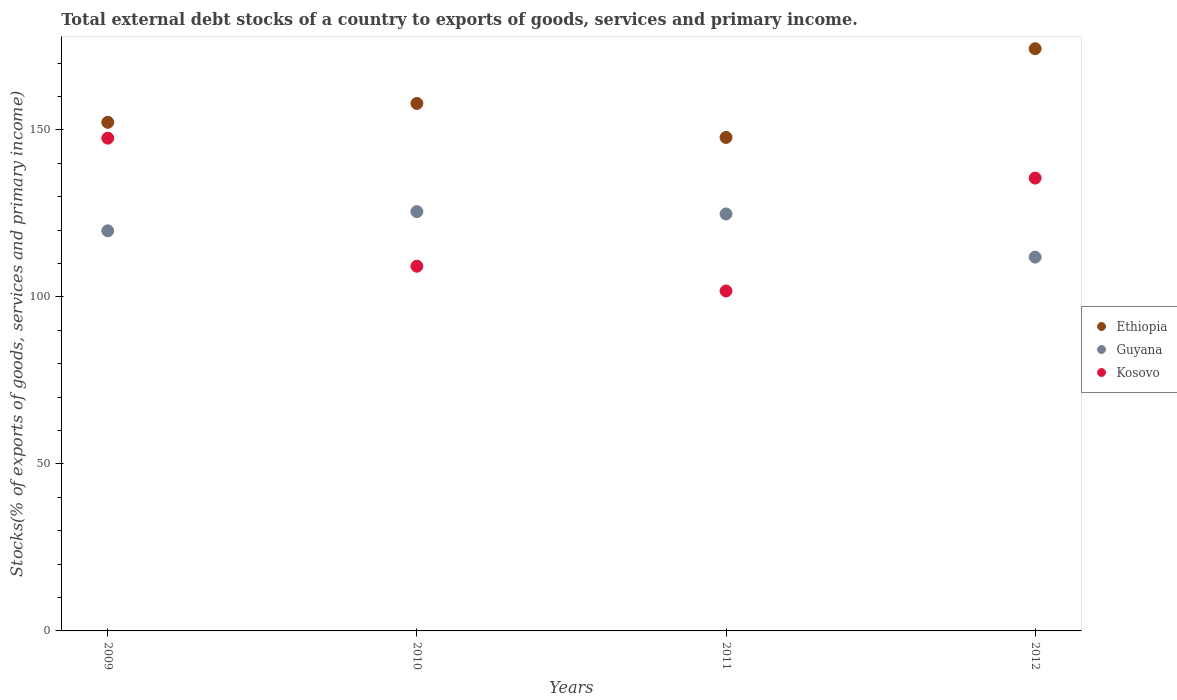What is the total debt stocks in Kosovo in 2010?
Provide a succinct answer. 109.18. Across all years, what is the maximum total debt stocks in Guyana?
Your answer should be compact. 125.53. Across all years, what is the minimum total debt stocks in Ethiopia?
Offer a terse response. 147.73. In which year was the total debt stocks in Guyana maximum?
Offer a very short reply. 2010. What is the total total debt stocks in Guyana in the graph?
Ensure brevity in your answer.  482.04. What is the difference between the total debt stocks in Kosovo in 2011 and that in 2012?
Keep it short and to the point. -33.81. What is the difference between the total debt stocks in Ethiopia in 2011 and the total debt stocks in Guyana in 2009?
Offer a very short reply. 27.95. What is the average total debt stocks in Ethiopia per year?
Ensure brevity in your answer.  158.05. In the year 2011, what is the difference between the total debt stocks in Ethiopia and total debt stocks in Kosovo?
Your answer should be very brief. 45.97. In how many years, is the total debt stocks in Guyana greater than 160 %?
Make the answer very short. 0. What is the ratio of the total debt stocks in Kosovo in 2009 to that in 2012?
Offer a terse response. 1.09. Is the total debt stocks in Kosovo in 2009 less than that in 2010?
Keep it short and to the point. No. Is the difference between the total debt stocks in Ethiopia in 2009 and 2012 greater than the difference between the total debt stocks in Kosovo in 2009 and 2012?
Offer a terse response. No. What is the difference between the highest and the second highest total debt stocks in Guyana?
Provide a short and direct response. 0.71. What is the difference between the highest and the lowest total debt stocks in Ethiopia?
Provide a short and direct response. 26.56. Is the sum of the total debt stocks in Kosovo in 2009 and 2012 greater than the maximum total debt stocks in Guyana across all years?
Offer a terse response. Yes. Is it the case that in every year, the sum of the total debt stocks in Guyana and total debt stocks in Ethiopia  is greater than the total debt stocks in Kosovo?
Your answer should be compact. Yes. Is the total debt stocks in Kosovo strictly less than the total debt stocks in Ethiopia over the years?
Provide a succinct answer. Yes. How many years are there in the graph?
Your answer should be very brief. 4. What is the difference between two consecutive major ticks on the Y-axis?
Give a very brief answer. 50. Are the values on the major ticks of Y-axis written in scientific E-notation?
Give a very brief answer. No. What is the title of the graph?
Your answer should be very brief. Total external debt stocks of a country to exports of goods, services and primary income. What is the label or title of the Y-axis?
Give a very brief answer. Stocks(% of exports of goods, services and primary income). What is the Stocks(% of exports of goods, services and primary income) in Ethiopia in 2009?
Make the answer very short. 152.26. What is the Stocks(% of exports of goods, services and primary income) of Guyana in 2009?
Make the answer very short. 119.78. What is the Stocks(% of exports of goods, services and primary income) of Kosovo in 2009?
Offer a very short reply. 147.52. What is the Stocks(% of exports of goods, services and primary income) in Ethiopia in 2010?
Your response must be concise. 157.91. What is the Stocks(% of exports of goods, services and primary income) in Guyana in 2010?
Provide a short and direct response. 125.53. What is the Stocks(% of exports of goods, services and primary income) in Kosovo in 2010?
Offer a very short reply. 109.18. What is the Stocks(% of exports of goods, services and primary income) in Ethiopia in 2011?
Keep it short and to the point. 147.73. What is the Stocks(% of exports of goods, services and primary income) in Guyana in 2011?
Provide a succinct answer. 124.82. What is the Stocks(% of exports of goods, services and primary income) in Kosovo in 2011?
Your response must be concise. 101.76. What is the Stocks(% of exports of goods, services and primary income) in Ethiopia in 2012?
Keep it short and to the point. 174.3. What is the Stocks(% of exports of goods, services and primary income) in Guyana in 2012?
Ensure brevity in your answer.  111.91. What is the Stocks(% of exports of goods, services and primary income) of Kosovo in 2012?
Offer a very short reply. 135.57. Across all years, what is the maximum Stocks(% of exports of goods, services and primary income) in Ethiopia?
Offer a terse response. 174.3. Across all years, what is the maximum Stocks(% of exports of goods, services and primary income) in Guyana?
Your answer should be compact. 125.53. Across all years, what is the maximum Stocks(% of exports of goods, services and primary income) of Kosovo?
Make the answer very short. 147.52. Across all years, what is the minimum Stocks(% of exports of goods, services and primary income) of Ethiopia?
Make the answer very short. 147.73. Across all years, what is the minimum Stocks(% of exports of goods, services and primary income) in Guyana?
Your response must be concise. 111.91. Across all years, what is the minimum Stocks(% of exports of goods, services and primary income) of Kosovo?
Your response must be concise. 101.76. What is the total Stocks(% of exports of goods, services and primary income) of Ethiopia in the graph?
Your answer should be compact. 632.21. What is the total Stocks(% of exports of goods, services and primary income) in Guyana in the graph?
Make the answer very short. 482.04. What is the total Stocks(% of exports of goods, services and primary income) of Kosovo in the graph?
Your answer should be compact. 494.03. What is the difference between the Stocks(% of exports of goods, services and primary income) of Ethiopia in 2009 and that in 2010?
Ensure brevity in your answer.  -5.64. What is the difference between the Stocks(% of exports of goods, services and primary income) in Guyana in 2009 and that in 2010?
Ensure brevity in your answer.  -5.75. What is the difference between the Stocks(% of exports of goods, services and primary income) of Kosovo in 2009 and that in 2010?
Your answer should be compact. 38.34. What is the difference between the Stocks(% of exports of goods, services and primary income) of Ethiopia in 2009 and that in 2011?
Your response must be concise. 4.53. What is the difference between the Stocks(% of exports of goods, services and primary income) of Guyana in 2009 and that in 2011?
Make the answer very short. -5.04. What is the difference between the Stocks(% of exports of goods, services and primary income) of Kosovo in 2009 and that in 2011?
Your answer should be compact. 45.76. What is the difference between the Stocks(% of exports of goods, services and primary income) in Ethiopia in 2009 and that in 2012?
Your answer should be compact. -22.03. What is the difference between the Stocks(% of exports of goods, services and primary income) of Guyana in 2009 and that in 2012?
Offer a very short reply. 7.87. What is the difference between the Stocks(% of exports of goods, services and primary income) of Kosovo in 2009 and that in 2012?
Offer a very short reply. 11.95. What is the difference between the Stocks(% of exports of goods, services and primary income) of Ethiopia in 2010 and that in 2011?
Your answer should be very brief. 10.17. What is the difference between the Stocks(% of exports of goods, services and primary income) of Guyana in 2010 and that in 2011?
Your answer should be compact. 0.71. What is the difference between the Stocks(% of exports of goods, services and primary income) in Kosovo in 2010 and that in 2011?
Provide a short and direct response. 7.42. What is the difference between the Stocks(% of exports of goods, services and primary income) in Ethiopia in 2010 and that in 2012?
Your response must be concise. -16.39. What is the difference between the Stocks(% of exports of goods, services and primary income) of Guyana in 2010 and that in 2012?
Make the answer very short. 13.62. What is the difference between the Stocks(% of exports of goods, services and primary income) of Kosovo in 2010 and that in 2012?
Your answer should be very brief. -26.39. What is the difference between the Stocks(% of exports of goods, services and primary income) in Ethiopia in 2011 and that in 2012?
Offer a terse response. -26.56. What is the difference between the Stocks(% of exports of goods, services and primary income) in Guyana in 2011 and that in 2012?
Ensure brevity in your answer.  12.91. What is the difference between the Stocks(% of exports of goods, services and primary income) of Kosovo in 2011 and that in 2012?
Provide a succinct answer. -33.81. What is the difference between the Stocks(% of exports of goods, services and primary income) in Ethiopia in 2009 and the Stocks(% of exports of goods, services and primary income) in Guyana in 2010?
Provide a short and direct response. 26.74. What is the difference between the Stocks(% of exports of goods, services and primary income) in Ethiopia in 2009 and the Stocks(% of exports of goods, services and primary income) in Kosovo in 2010?
Keep it short and to the point. 43.09. What is the difference between the Stocks(% of exports of goods, services and primary income) of Guyana in 2009 and the Stocks(% of exports of goods, services and primary income) of Kosovo in 2010?
Provide a short and direct response. 10.6. What is the difference between the Stocks(% of exports of goods, services and primary income) of Ethiopia in 2009 and the Stocks(% of exports of goods, services and primary income) of Guyana in 2011?
Provide a short and direct response. 27.44. What is the difference between the Stocks(% of exports of goods, services and primary income) in Ethiopia in 2009 and the Stocks(% of exports of goods, services and primary income) in Kosovo in 2011?
Give a very brief answer. 50.5. What is the difference between the Stocks(% of exports of goods, services and primary income) of Guyana in 2009 and the Stocks(% of exports of goods, services and primary income) of Kosovo in 2011?
Ensure brevity in your answer.  18.02. What is the difference between the Stocks(% of exports of goods, services and primary income) in Ethiopia in 2009 and the Stocks(% of exports of goods, services and primary income) in Guyana in 2012?
Your response must be concise. 40.36. What is the difference between the Stocks(% of exports of goods, services and primary income) in Ethiopia in 2009 and the Stocks(% of exports of goods, services and primary income) in Kosovo in 2012?
Provide a short and direct response. 16.7. What is the difference between the Stocks(% of exports of goods, services and primary income) of Guyana in 2009 and the Stocks(% of exports of goods, services and primary income) of Kosovo in 2012?
Provide a short and direct response. -15.79. What is the difference between the Stocks(% of exports of goods, services and primary income) in Ethiopia in 2010 and the Stocks(% of exports of goods, services and primary income) in Guyana in 2011?
Provide a succinct answer. 33.09. What is the difference between the Stocks(% of exports of goods, services and primary income) of Ethiopia in 2010 and the Stocks(% of exports of goods, services and primary income) of Kosovo in 2011?
Keep it short and to the point. 56.15. What is the difference between the Stocks(% of exports of goods, services and primary income) of Guyana in 2010 and the Stocks(% of exports of goods, services and primary income) of Kosovo in 2011?
Your answer should be very brief. 23.77. What is the difference between the Stocks(% of exports of goods, services and primary income) of Ethiopia in 2010 and the Stocks(% of exports of goods, services and primary income) of Guyana in 2012?
Ensure brevity in your answer.  46. What is the difference between the Stocks(% of exports of goods, services and primary income) of Ethiopia in 2010 and the Stocks(% of exports of goods, services and primary income) of Kosovo in 2012?
Provide a succinct answer. 22.34. What is the difference between the Stocks(% of exports of goods, services and primary income) of Guyana in 2010 and the Stocks(% of exports of goods, services and primary income) of Kosovo in 2012?
Make the answer very short. -10.04. What is the difference between the Stocks(% of exports of goods, services and primary income) of Ethiopia in 2011 and the Stocks(% of exports of goods, services and primary income) of Guyana in 2012?
Offer a very short reply. 35.83. What is the difference between the Stocks(% of exports of goods, services and primary income) of Ethiopia in 2011 and the Stocks(% of exports of goods, services and primary income) of Kosovo in 2012?
Your answer should be compact. 12.17. What is the difference between the Stocks(% of exports of goods, services and primary income) in Guyana in 2011 and the Stocks(% of exports of goods, services and primary income) in Kosovo in 2012?
Keep it short and to the point. -10.75. What is the average Stocks(% of exports of goods, services and primary income) of Ethiopia per year?
Provide a short and direct response. 158.05. What is the average Stocks(% of exports of goods, services and primary income) of Guyana per year?
Offer a very short reply. 120.51. What is the average Stocks(% of exports of goods, services and primary income) of Kosovo per year?
Your response must be concise. 123.51. In the year 2009, what is the difference between the Stocks(% of exports of goods, services and primary income) in Ethiopia and Stocks(% of exports of goods, services and primary income) in Guyana?
Ensure brevity in your answer.  32.48. In the year 2009, what is the difference between the Stocks(% of exports of goods, services and primary income) of Ethiopia and Stocks(% of exports of goods, services and primary income) of Kosovo?
Provide a succinct answer. 4.74. In the year 2009, what is the difference between the Stocks(% of exports of goods, services and primary income) in Guyana and Stocks(% of exports of goods, services and primary income) in Kosovo?
Offer a very short reply. -27.74. In the year 2010, what is the difference between the Stocks(% of exports of goods, services and primary income) in Ethiopia and Stocks(% of exports of goods, services and primary income) in Guyana?
Provide a succinct answer. 32.38. In the year 2010, what is the difference between the Stocks(% of exports of goods, services and primary income) in Ethiopia and Stocks(% of exports of goods, services and primary income) in Kosovo?
Your answer should be very brief. 48.73. In the year 2010, what is the difference between the Stocks(% of exports of goods, services and primary income) of Guyana and Stocks(% of exports of goods, services and primary income) of Kosovo?
Your answer should be very brief. 16.35. In the year 2011, what is the difference between the Stocks(% of exports of goods, services and primary income) in Ethiopia and Stocks(% of exports of goods, services and primary income) in Guyana?
Provide a succinct answer. 22.91. In the year 2011, what is the difference between the Stocks(% of exports of goods, services and primary income) in Ethiopia and Stocks(% of exports of goods, services and primary income) in Kosovo?
Your answer should be compact. 45.97. In the year 2011, what is the difference between the Stocks(% of exports of goods, services and primary income) in Guyana and Stocks(% of exports of goods, services and primary income) in Kosovo?
Give a very brief answer. 23.06. In the year 2012, what is the difference between the Stocks(% of exports of goods, services and primary income) of Ethiopia and Stocks(% of exports of goods, services and primary income) of Guyana?
Your response must be concise. 62.39. In the year 2012, what is the difference between the Stocks(% of exports of goods, services and primary income) of Ethiopia and Stocks(% of exports of goods, services and primary income) of Kosovo?
Ensure brevity in your answer.  38.73. In the year 2012, what is the difference between the Stocks(% of exports of goods, services and primary income) in Guyana and Stocks(% of exports of goods, services and primary income) in Kosovo?
Ensure brevity in your answer.  -23.66. What is the ratio of the Stocks(% of exports of goods, services and primary income) in Guyana in 2009 to that in 2010?
Make the answer very short. 0.95. What is the ratio of the Stocks(% of exports of goods, services and primary income) in Kosovo in 2009 to that in 2010?
Keep it short and to the point. 1.35. What is the ratio of the Stocks(% of exports of goods, services and primary income) of Ethiopia in 2009 to that in 2011?
Offer a very short reply. 1.03. What is the ratio of the Stocks(% of exports of goods, services and primary income) in Guyana in 2009 to that in 2011?
Offer a very short reply. 0.96. What is the ratio of the Stocks(% of exports of goods, services and primary income) of Kosovo in 2009 to that in 2011?
Offer a terse response. 1.45. What is the ratio of the Stocks(% of exports of goods, services and primary income) in Ethiopia in 2009 to that in 2012?
Provide a short and direct response. 0.87. What is the ratio of the Stocks(% of exports of goods, services and primary income) in Guyana in 2009 to that in 2012?
Provide a succinct answer. 1.07. What is the ratio of the Stocks(% of exports of goods, services and primary income) of Kosovo in 2009 to that in 2012?
Provide a short and direct response. 1.09. What is the ratio of the Stocks(% of exports of goods, services and primary income) in Ethiopia in 2010 to that in 2011?
Keep it short and to the point. 1.07. What is the ratio of the Stocks(% of exports of goods, services and primary income) in Kosovo in 2010 to that in 2011?
Offer a terse response. 1.07. What is the ratio of the Stocks(% of exports of goods, services and primary income) of Ethiopia in 2010 to that in 2012?
Provide a short and direct response. 0.91. What is the ratio of the Stocks(% of exports of goods, services and primary income) in Guyana in 2010 to that in 2012?
Your response must be concise. 1.12. What is the ratio of the Stocks(% of exports of goods, services and primary income) in Kosovo in 2010 to that in 2012?
Offer a very short reply. 0.81. What is the ratio of the Stocks(% of exports of goods, services and primary income) of Ethiopia in 2011 to that in 2012?
Make the answer very short. 0.85. What is the ratio of the Stocks(% of exports of goods, services and primary income) of Guyana in 2011 to that in 2012?
Keep it short and to the point. 1.12. What is the ratio of the Stocks(% of exports of goods, services and primary income) of Kosovo in 2011 to that in 2012?
Provide a succinct answer. 0.75. What is the difference between the highest and the second highest Stocks(% of exports of goods, services and primary income) of Ethiopia?
Your response must be concise. 16.39. What is the difference between the highest and the second highest Stocks(% of exports of goods, services and primary income) in Guyana?
Offer a very short reply. 0.71. What is the difference between the highest and the second highest Stocks(% of exports of goods, services and primary income) in Kosovo?
Your answer should be compact. 11.95. What is the difference between the highest and the lowest Stocks(% of exports of goods, services and primary income) in Ethiopia?
Offer a terse response. 26.56. What is the difference between the highest and the lowest Stocks(% of exports of goods, services and primary income) of Guyana?
Ensure brevity in your answer.  13.62. What is the difference between the highest and the lowest Stocks(% of exports of goods, services and primary income) of Kosovo?
Your response must be concise. 45.76. 